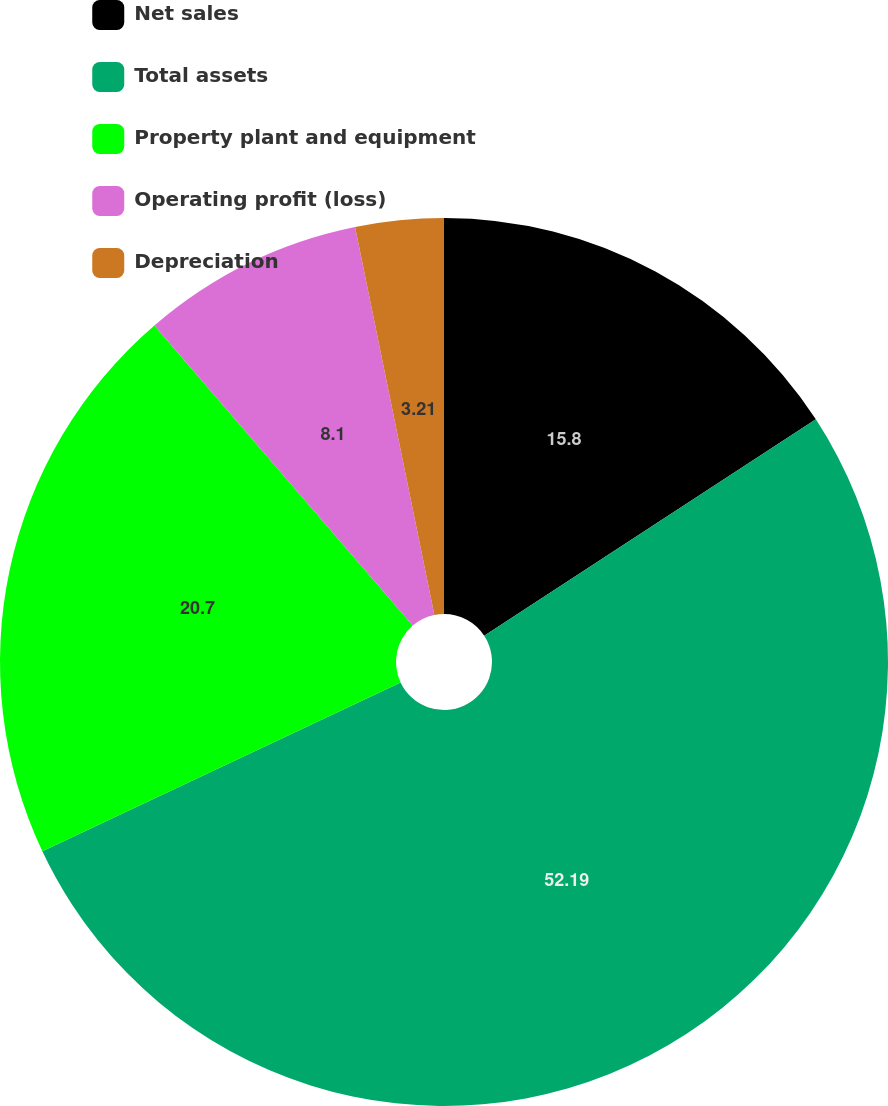<chart> <loc_0><loc_0><loc_500><loc_500><pie_chart><fcel>Net sales<fcel>Total assets<fcel>Property plant and equipment<fcel>Operating profit (loss)<fcel>Depreciation<nl><fcel>15.8%<fcel>52.2%<fcel>20.7%<fcel>8.1%<fcel>3.21%<nl></chart> 